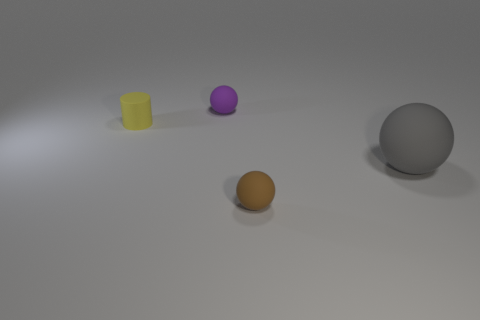Add 2 tiny rubber things. How many objects exist? 6 Subtract all tiny rubber spheres. How many spheres are left? 1 Subtract all cylinders. How many objects are left? 3 Subtract all blue spheres. Subtract all cyan blocks. How many spheres are left? 3 Subtract all balls. Subtract all small yellow things. How many objects are left? 0 Add 3 gray balls. How many gray balls are left? 4 Add 4 big purple spheres. How many big purple spheres exist? 4 Subtract 0 brown cubes. How many objects are left? 4 